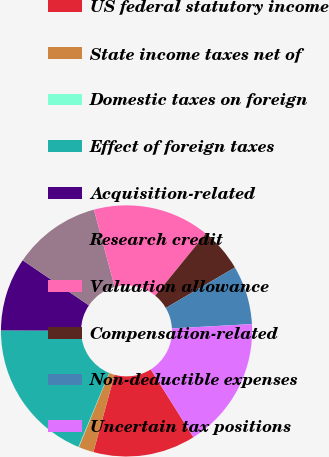Convert chart to OTSL. <chart><loc_0><loc_0><loc_500><loc_500><pie_chart><fcel>US federal statutory income<fcel>State income taxes net of<fcel>Domestic taxes on foreign<fcel>Effect of foreign taxes<fcel>Acquisition-related<fcel>Research credit<fcel>Valuation allowance<fcel>Compensation-related<fcel>Non-deductible expenses<fcel>Uncertain tax positions<nl><fcel>13.19%<fcel>1.94%<fcel>0.07%<fcel>18.81%<fcel>9.44%<fcel>11.31%<fcel>15.06%<fcel>5.69%<fcel>7.56%<fcel>16.93%<nl></chart> 